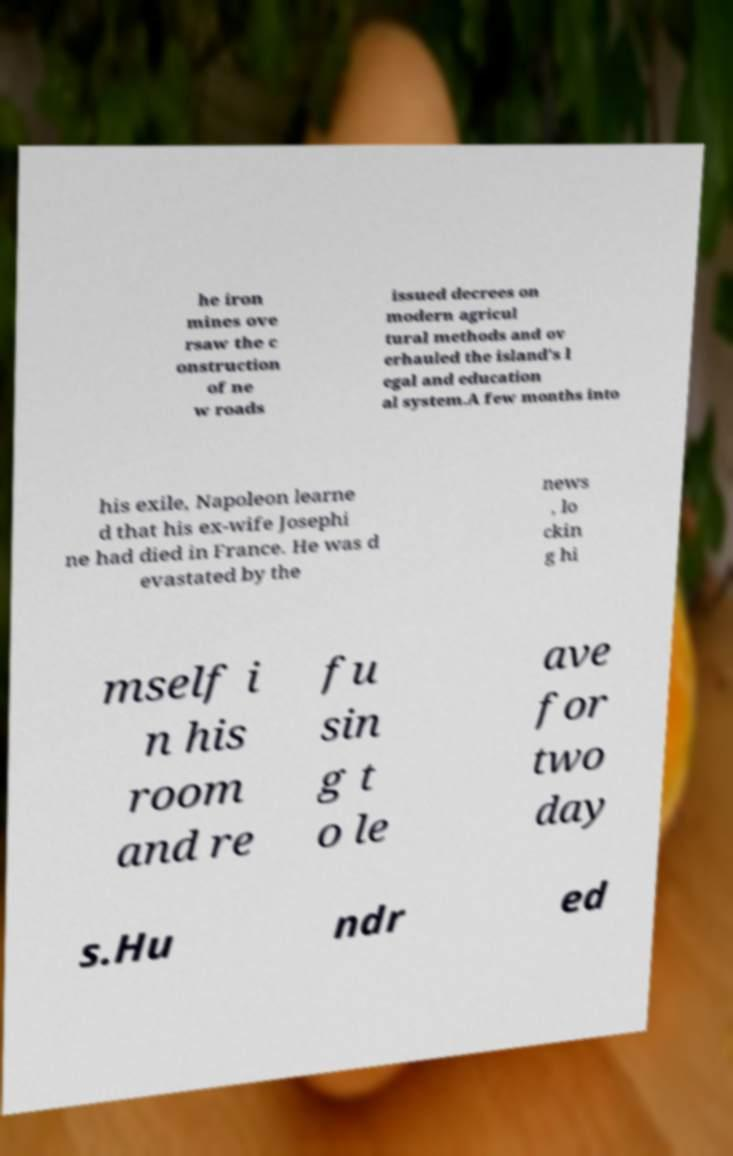I need the written content from this picture converted into text. Can you do that? he iron mines ove rsaw the c onstruction of ne w roads issued decrees on modern agricul tural methods and ov erhauled the island's l egal and education al system.A few months into his exile, Napoleon learne d that his ex-wife Josephi ne had died in France. He was d evastated by the news , lo ckin g hi mself i n his room and re fu sin g t o le ave for two day s.Hu ndr ed 